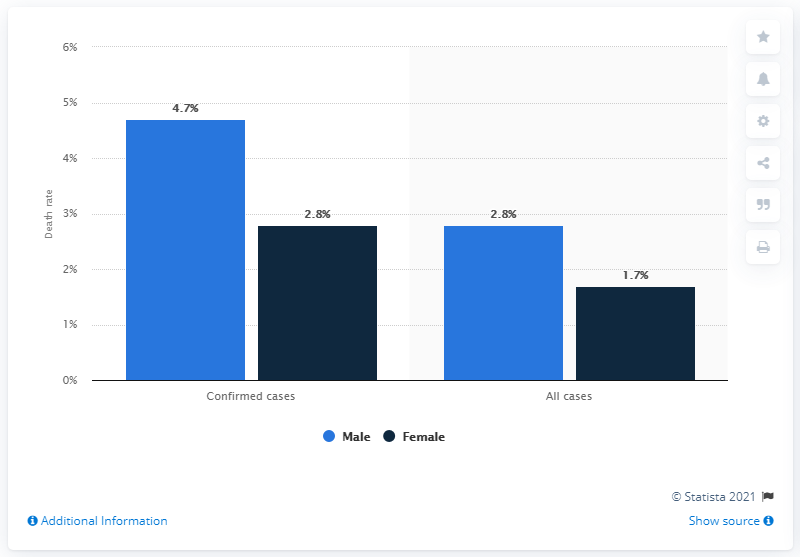List a handful of essential elements in this visual. The probability of male individuals dying as a result of coronavirus infection was 4.7%. The probability of dying as a result of a coronavirus infection among confirmed cases among females was 2.8%. There is a 2.8% probability of dying as a result of a coronavirus infection among confirmed female cases. 